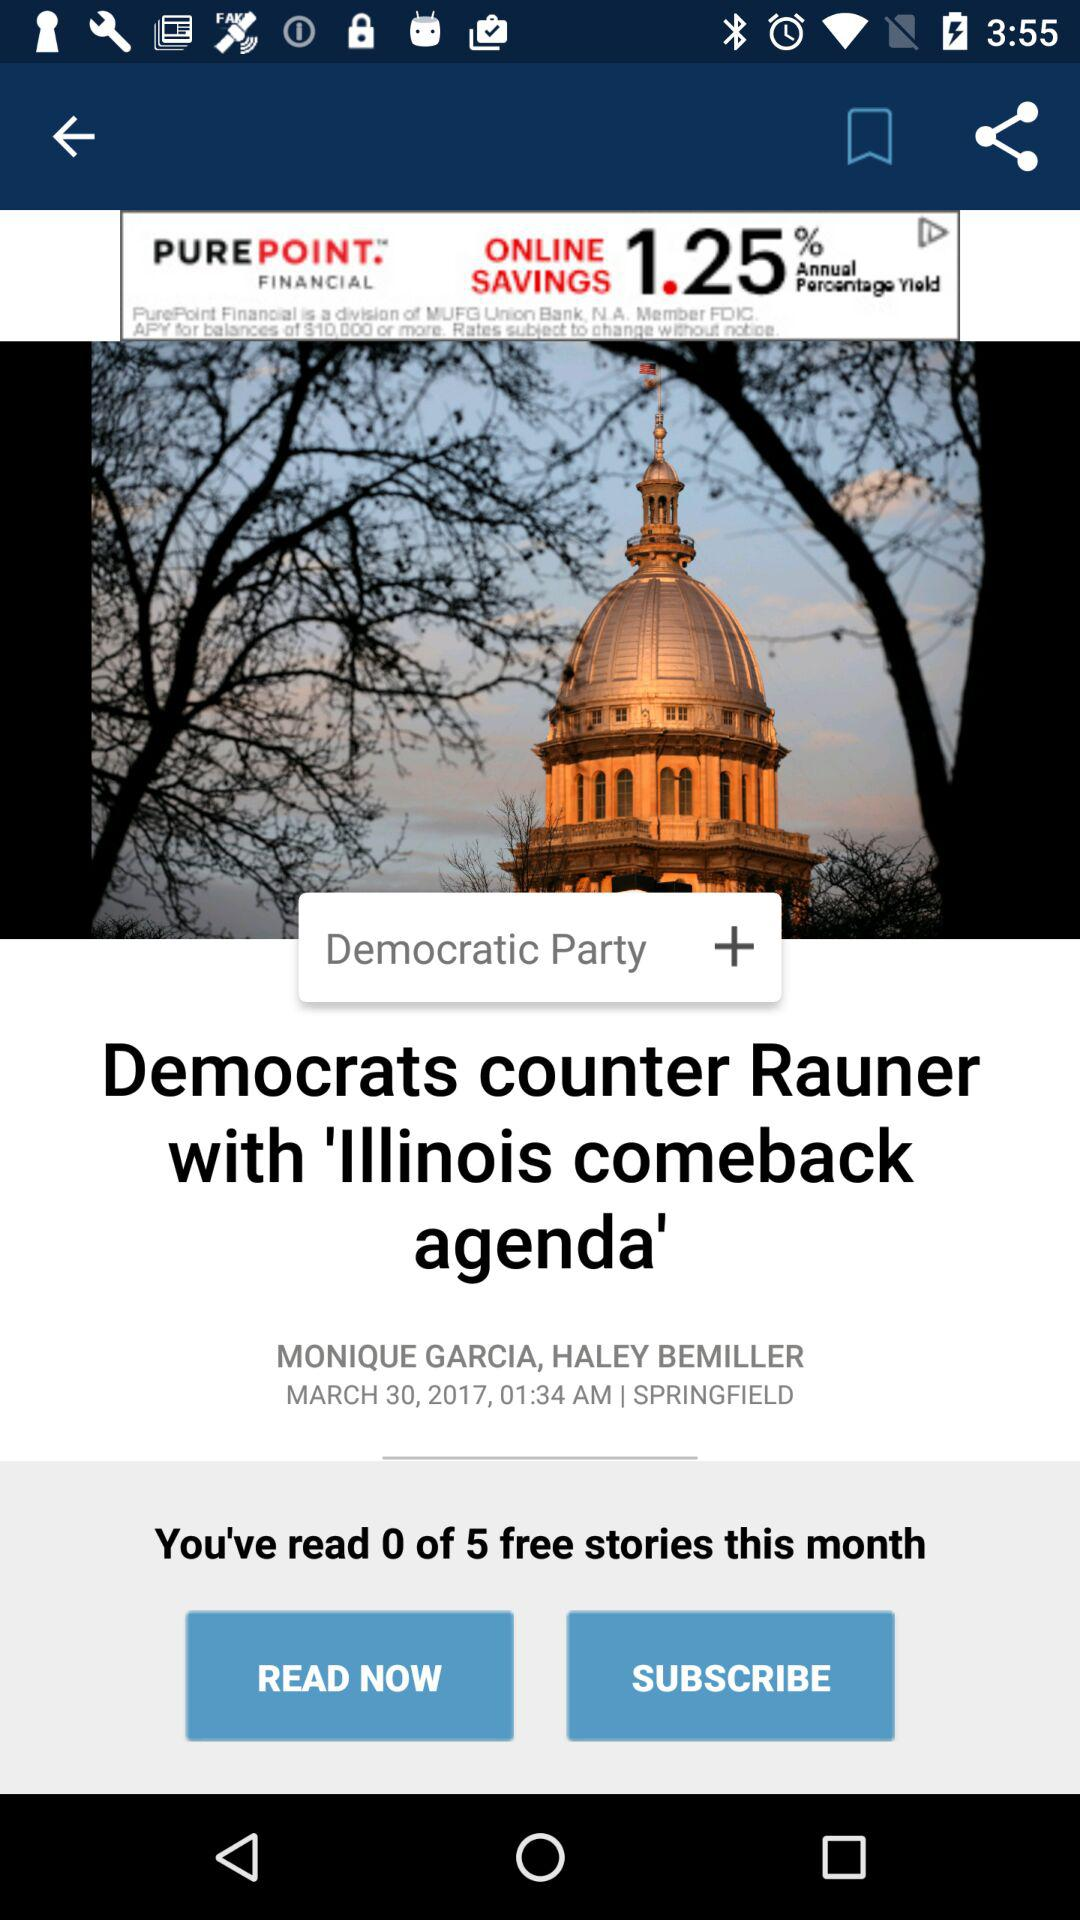How many free stories have I read this month?
Answer the question using a single word or phrase. 0 